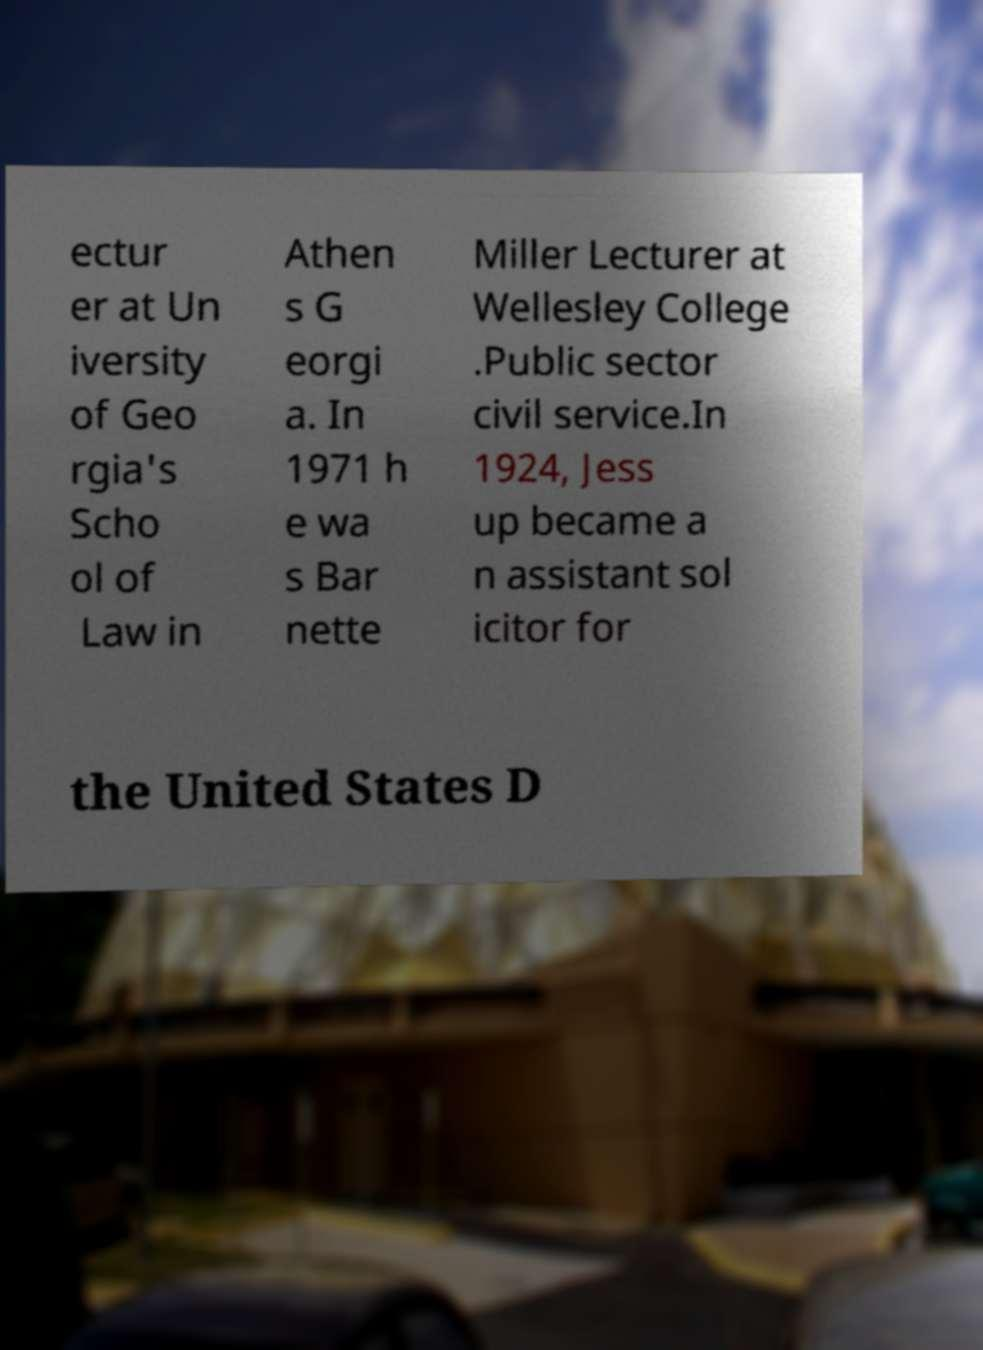Please read and relay the text visible in this image. What does it say? ectur er at Un iversity of Geo rgia's Scho ol of Law in Athen s G eorgi a. In 1971 h e wa s Bar nette Miller Lecturer at Wellesley College .Public sector civil service.In 1924, Jess up became a n assistant sol icitor for the United States D 